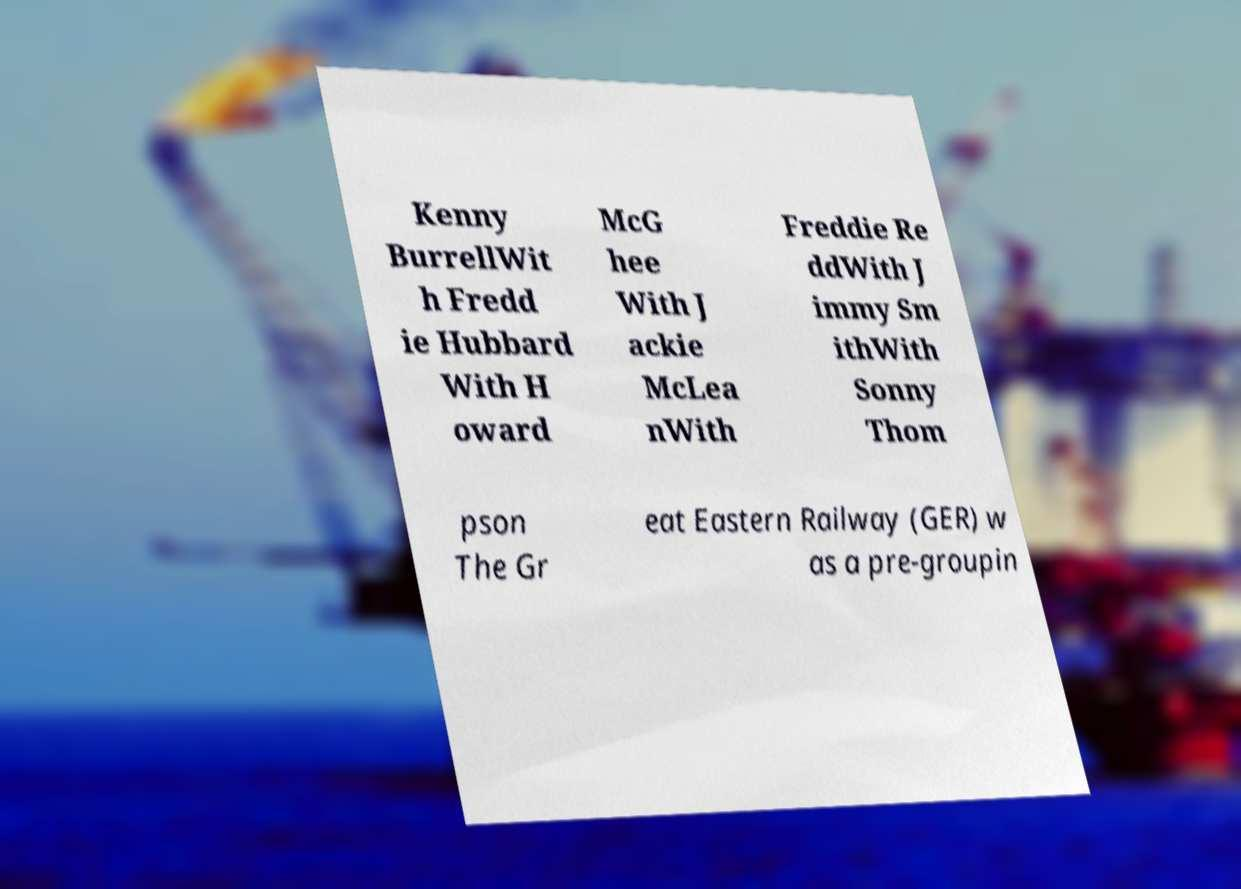I need the written content from this picture converted into text. Can you do that? Kenny BurrellWit h Fredd ie Hubbard With H oward McG hee With J ackie McLea nWith Freddie Re ddWith J immy Sm ithWith Sonny Thom pson The Gr eat Eastern Railway (GER) w as a pre-groupin 